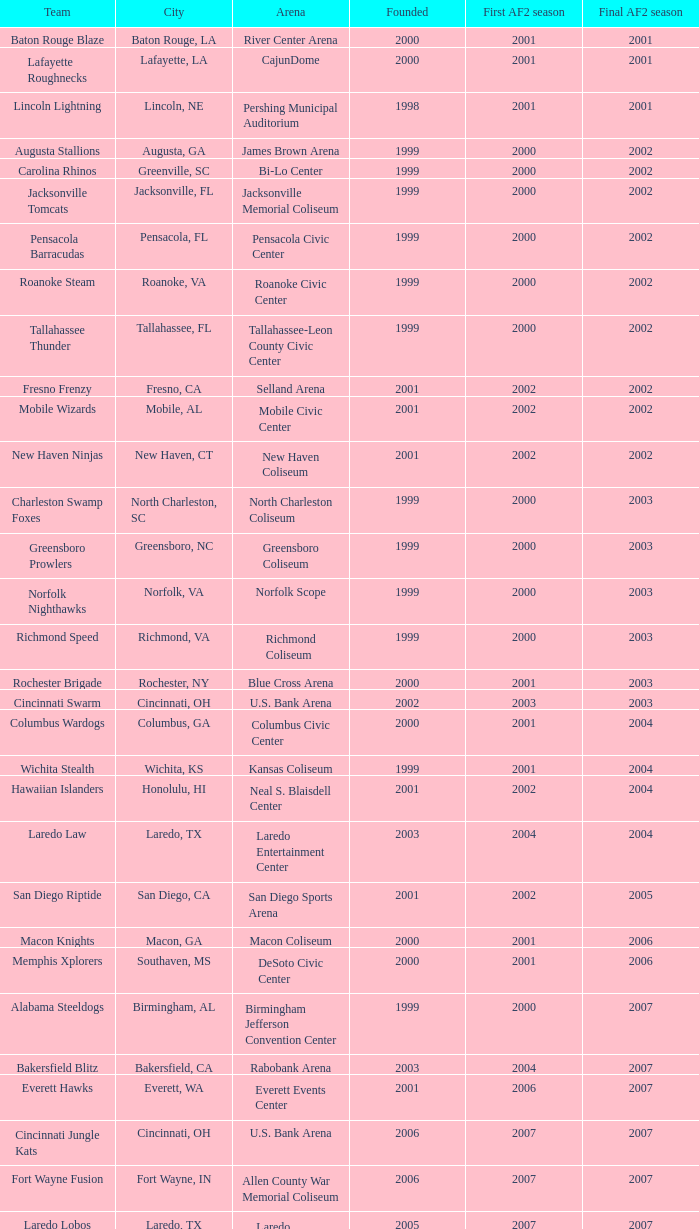What is the mean Founded number when the team is the Baton Rouge Blaze? 2000.0. 